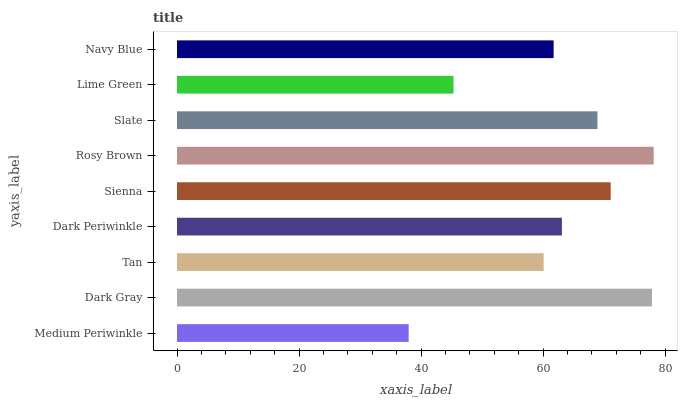Is Medium Periwinkle the minimum?
Answer yes or no. Yes. Is Rosy Brown the maximum?
Answer yes or no. Yes. Is Dark Gray the minimum?
Answer yes or no. No. Is Dark Gray the maximum?
Answer yes or no. No. Is Dark Gray greater than Medium Periwinkle?
Answer yes or no. Yes. Is Medium Periwinkle less than Dark Gray?
Answer yes or no. Yes. Is Medium Periwinkle greater than Dark Gray?
Answer yes or no. No. Is Dark Gray less than Medium Periwinkle?
Answer yes or no. No. Is Dark Periwinkle the high median?
Answer yes or no. Yes. Is Dark Periwinkle the low median?
Answer yes or no. Yes. Is Dark Gray the high median?
Answer yes or no. No. Is Rosy Brown the low median?
Answer yes or no. No. 